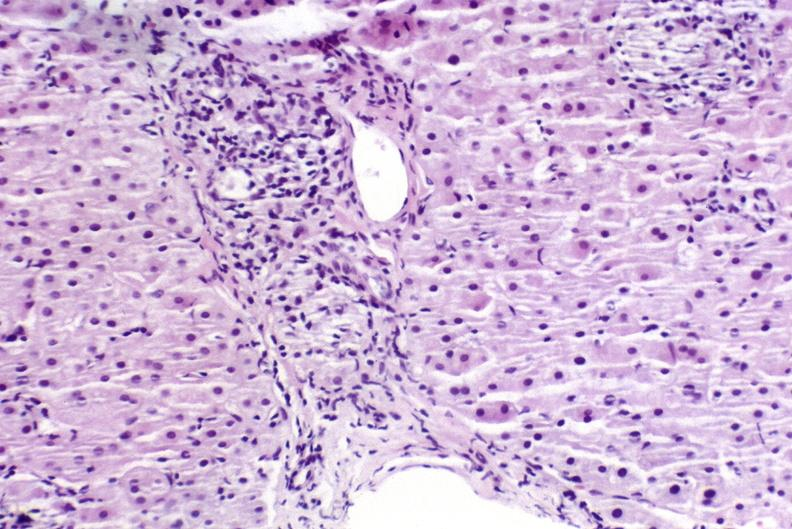s mucinous cystadenocarcinoma present?
Answer the question using a single word or phrase. No 